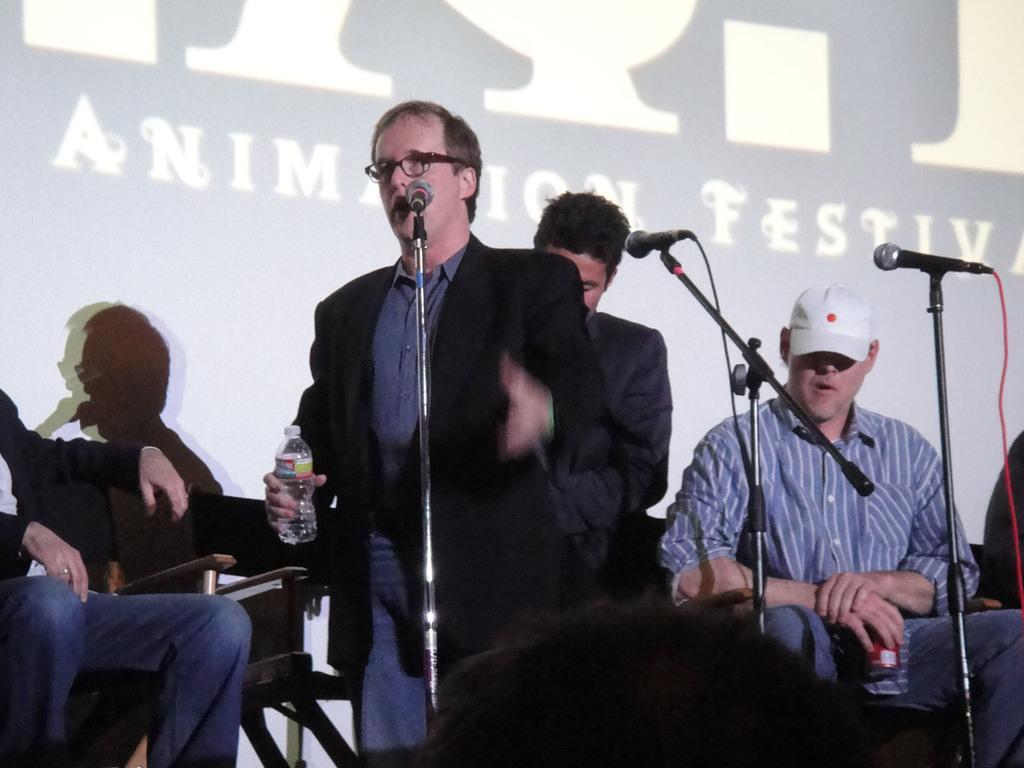Can you describe this image briefly? There are two men standing and two people sitting on the chairs. These are the mikes, which are attached to the mike stands. In the background, It might be a screen with the display. 